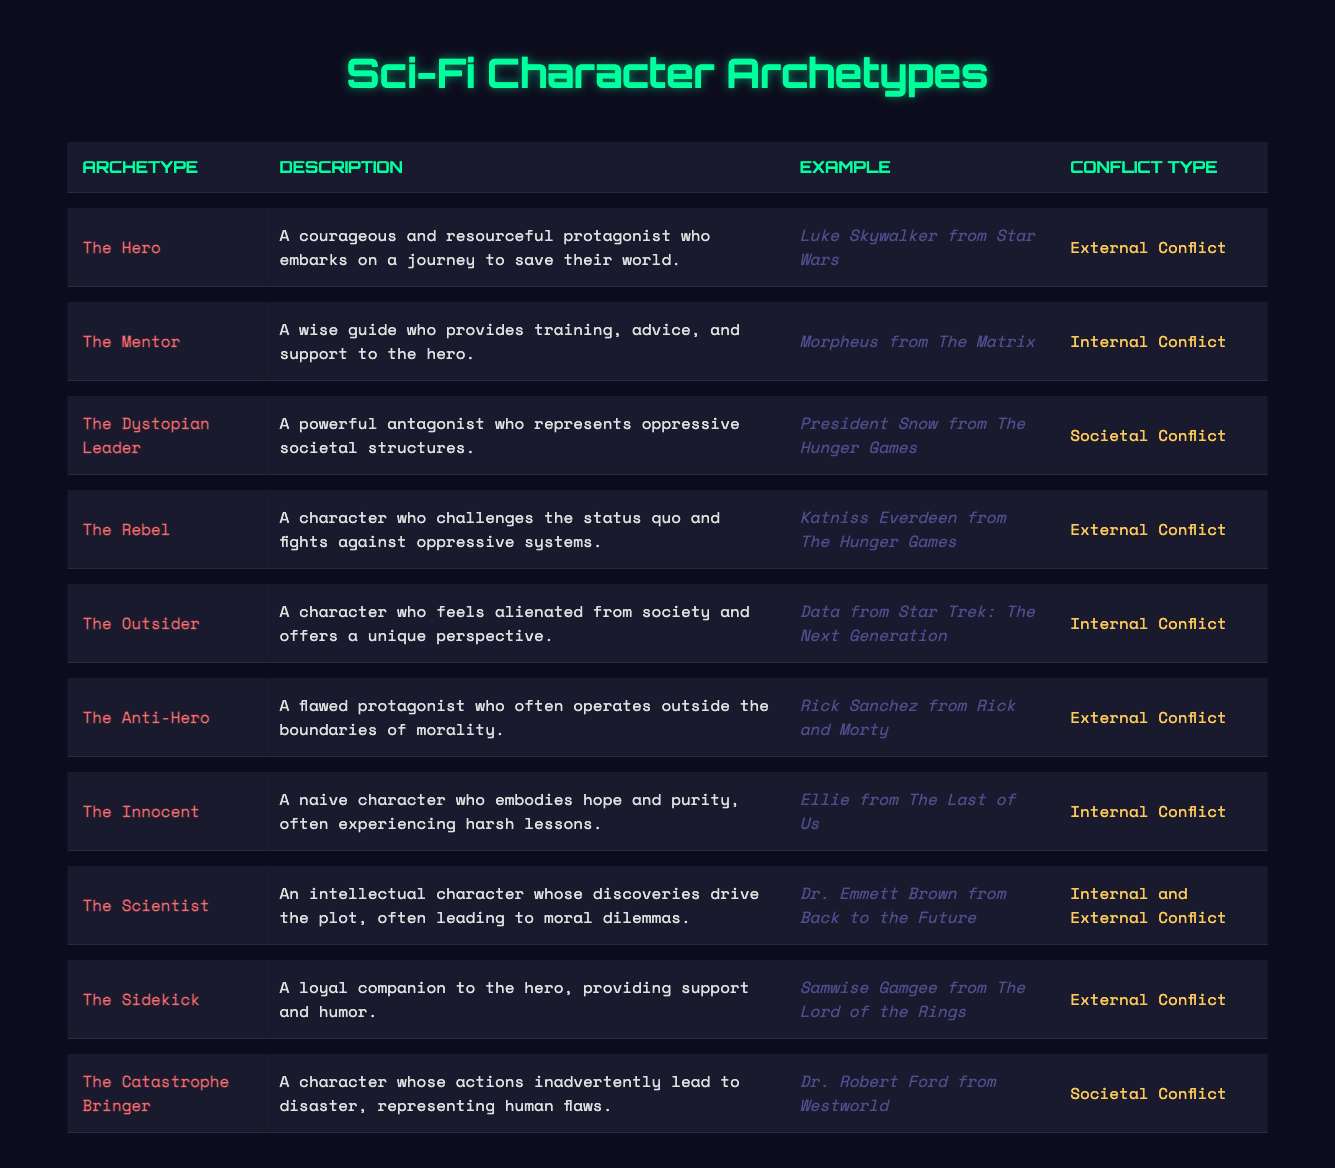What character archetype represents hope and purity? The table lists "The Innocent" as the character archetype that embodies hope and purity.
Answer: The Innocent Which archetype has an external conflict and challenges the status quo? "The Rebel" is identified in the table as a character who challenges the status quo and is associated with external conflict.
Answer: The Rebel Is "The Scientist" characterized by internal conflict? According to the table, "The Scientist" has both internal and external conflict types, which confirms that it indeed has internal conflict.
Answer: Yes How many characters are classified under societal conflict? The table lists two character archetypes: "The Dystopian Leader" and "The Catastrophe Bringer," indicating a total of two characters associated with societal conflict.
Answer: 2 Who is the outsider in the provided examples? The table shows "Data from Star Trek: The Next Generation" as the example of "The Outsider," which signifies someone who feels alienated from society.
Answer: Data from Star Trek: The Next Generation Which archetypes have external conflict? Determine the total. "The Hero," "The Rebel," "The Anti-Hero," "The Sidekick," and "The Catastrophe Bringer" are all listed as having external conflict. By counting them, we see there are 5 archetypes with external conflict.
Answer: 5 Which archetype describes a flawed protagonist? The archetype labeled "The Anti-Hero" is specifically described as a flawed protagonist operating outside moral boundaries.
Answer: The Anti-Hero Which character archetype serves as a wise guide? "The Mentor" is the character archetype described in the table as a wise guide, providing training and support to the hero.
Answer: The Mentor In total, how many character archetypes are listed in the table? By counting each entry in the table, we find there are 10 distinct character archetypes presented.
Answer: 10 